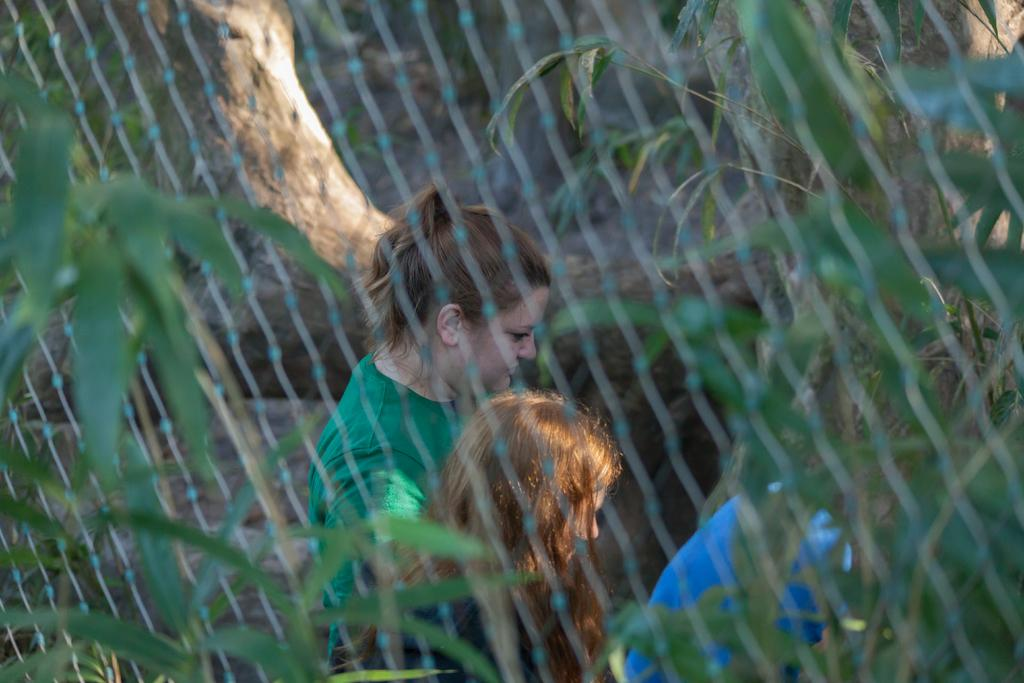What object is present in the image that can be used for catching or holding? There is a net in the image. What type of natural elements can be seen in the image? There are leaves in the image. Can you describe the people in the background of the image? There are two persons in the background of the image. What type of lipstick is the person wearing in the image? There are no persons wearing lipstick in the image, as it only features a net, leaves, and two persons in the background. 